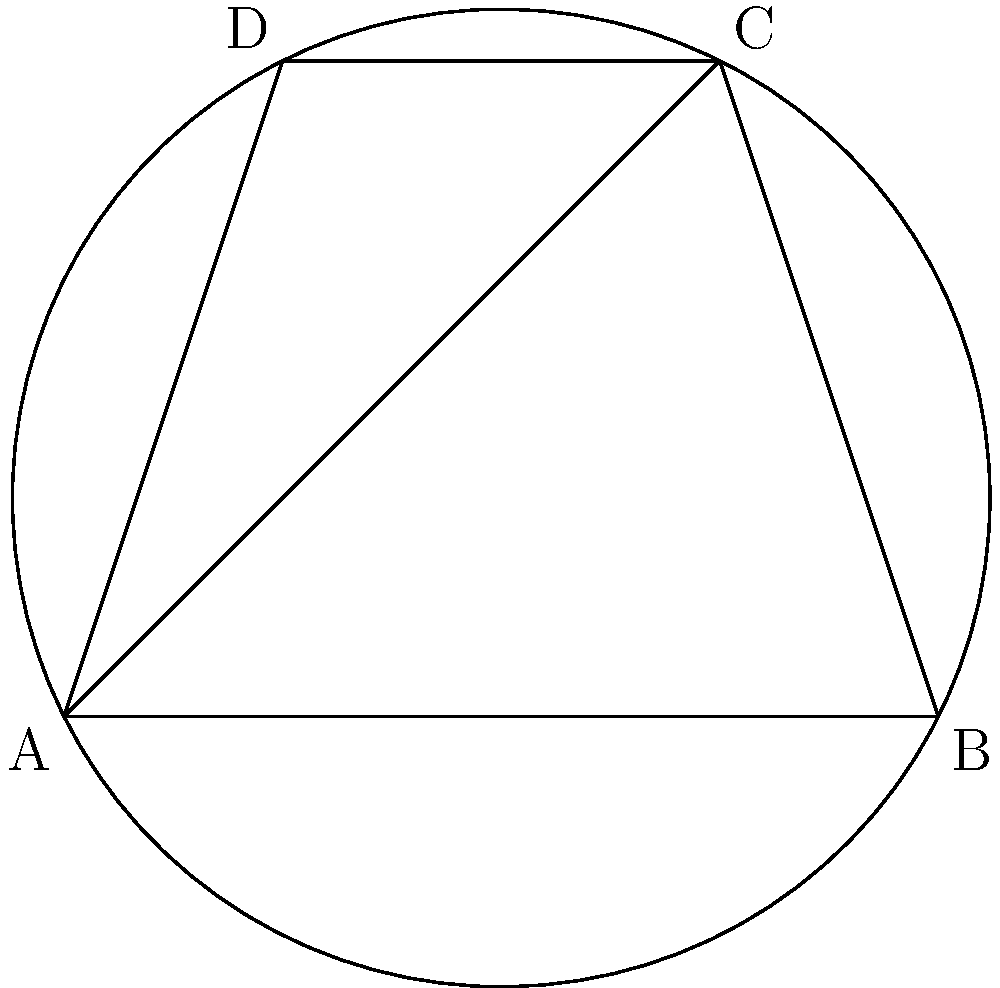In the cyclic quadrilateral ABCD, angle BAD is denoted as $\alpha$ and angle BCD is denoted as $\beta$. Which of the following statements is true about the relationship between $\alpha$ and $\beta$, and how does this reflect the principles of harmony in traditional Yi society? Let's approach this step-by-step:

1) In a cyclic quadrilateral, opposite angles are supplementary. This means that:
   $$\alpha + \beta = 180°$$

2) This relationship is due to the inscribed angle theorem, which states that an inscribed angle is half the central angle subtending the same arc.

3) The sum of the angles in a quadrilateral is always 360°. In a cyclic quadrilateral, this property combines with the supplementary opposite angles to create a balanced structure.

4) This balance in the quadrilateral can be seen as a reflection of the harmony and balance valued in traditional Yi society, where different elements complement each other to form a cohesive whole.

5) Just as the angles $\alpha$ and $\beta$ are interdependent and together form half of the total angle sum of the quadrilateral, individuals in Yi society are seen as interconnected parts of the community, each playing a vital role in maintaining social harmony.

6) The cyclic nature of the quadrilateral, inscribed in a circle, can also be related to the Yi people's traditional cyclical view of time and nature, emphasizing the interconnectedness of all things.

Therefore, the relationship $\alpha + \beta = 180°$ not only holds true mathematically but also serves as a metaphor for the balance and interconnectedness in Yi cultural philosophy.
Answer: $\alpha + \beta = 180°$ 